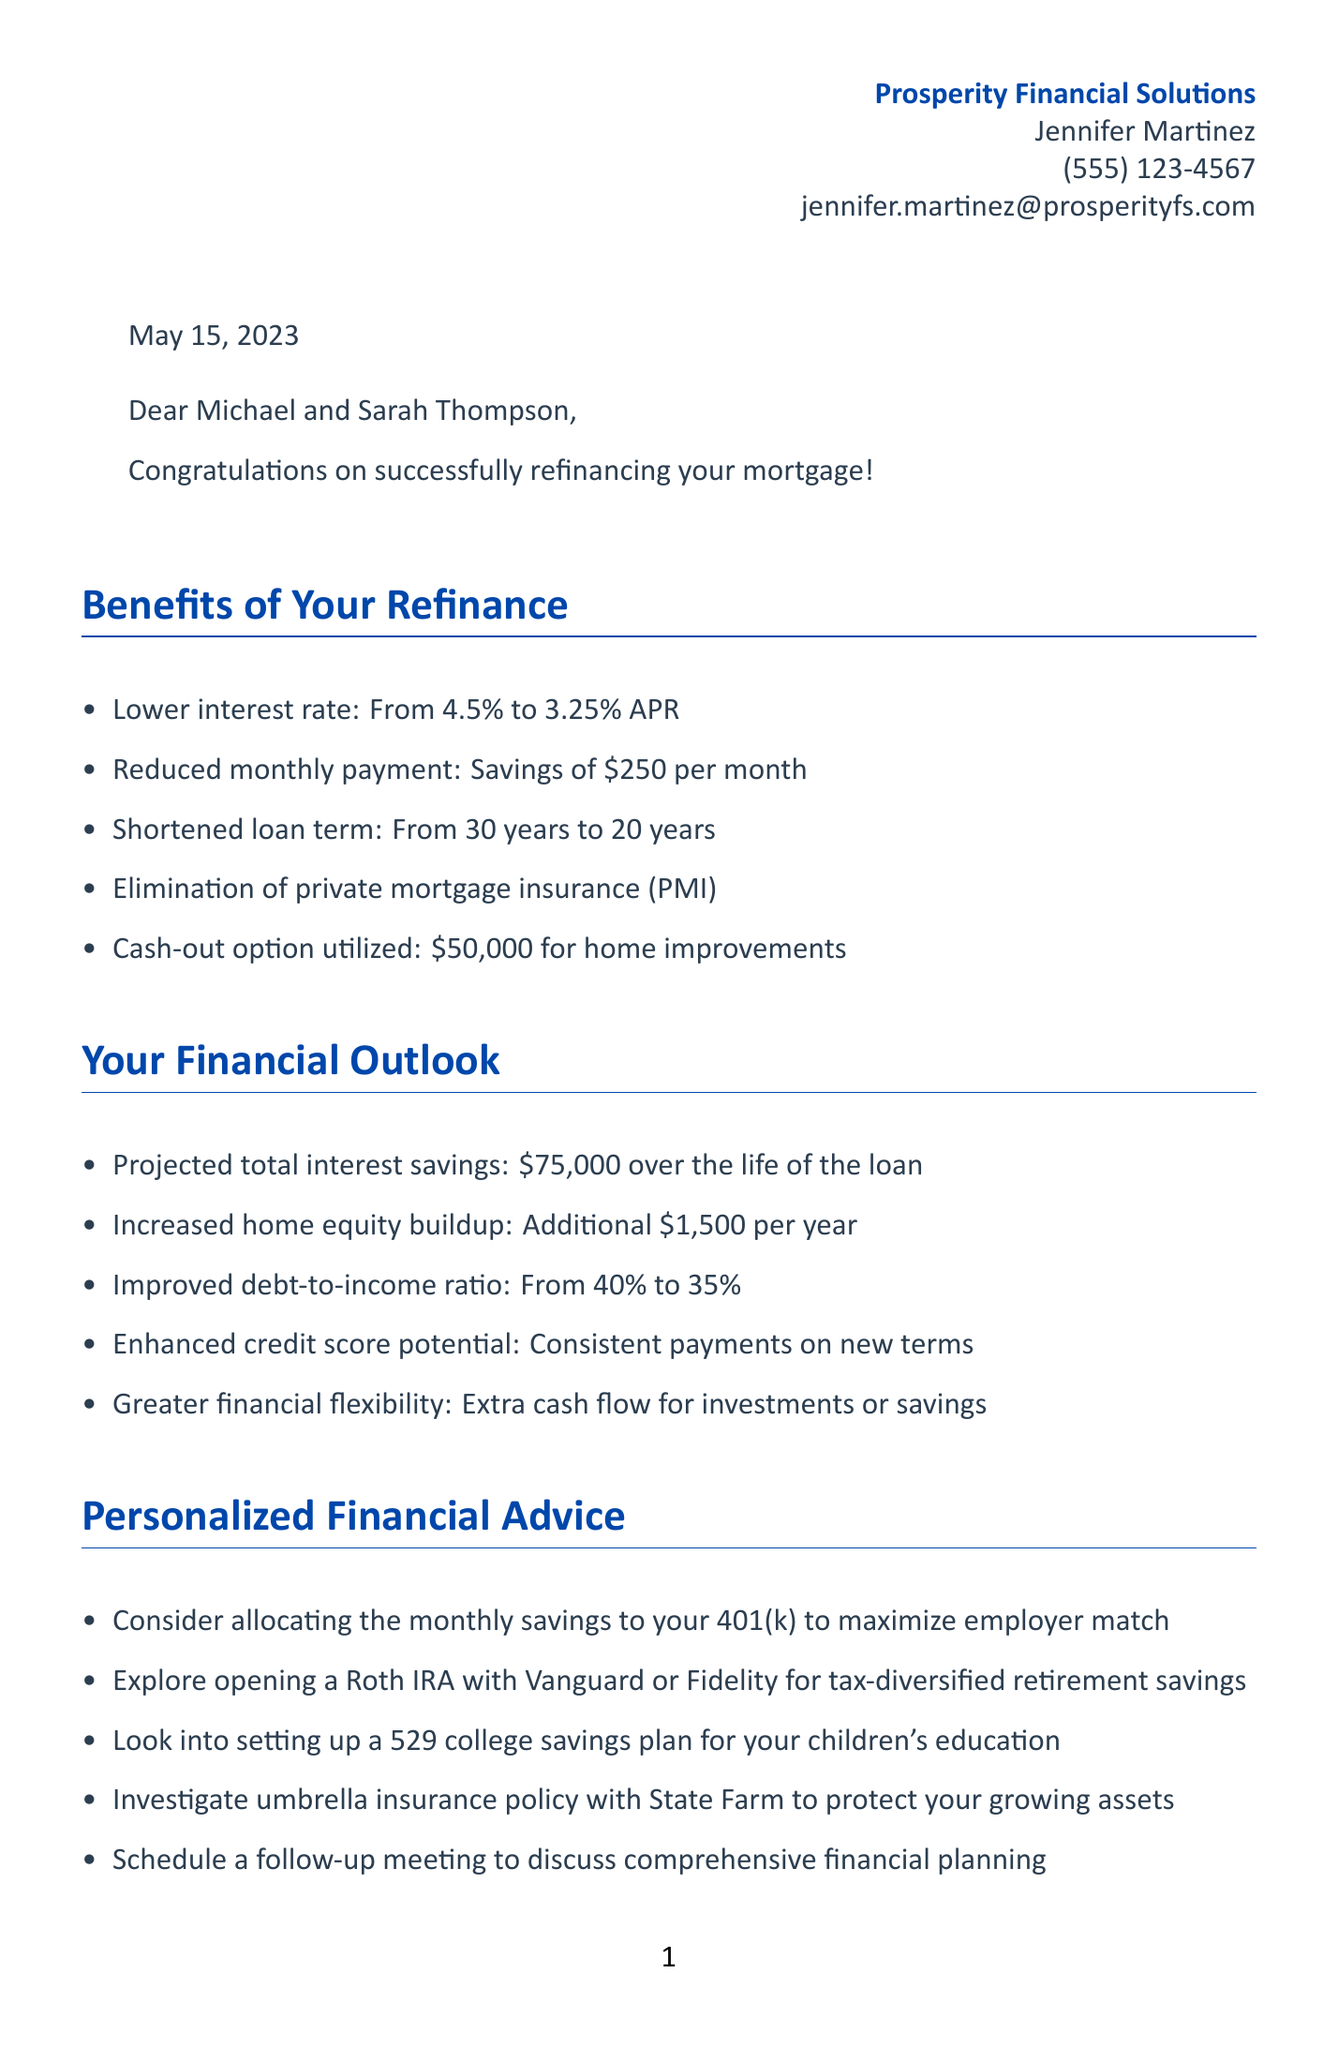What are the names of the clients? The document addresses Michael and Sarah Thompson, who are the clients.
Answer: Michael and Sarah Thompson What is the original lender's name? The document mentions that the clients' original lender was Bank of America.
Answer: Bank of America What is the new interest rate after refinancing? The document states that the interest rate was lowered to 3.25% APR after refinancing.
Answer: 3.25% APR What is the projected total interest savings? The total interest savings projected over the life of the loan is noted as $75,000.
Answer: $75,000 How much is the monthly savings? The clients are saving $250 per month on their mortgage payments as stated in the document.
Answer: $250 What should the clients do with their budget according to the next steps? The document advises the clients to update their budget to reflect the new monthly payment.
Answer: Update budget What financial planning topic is suggested for follow-up? The document suggests scheduling a follow-up meeting to discuss comprehensive financial planning.
Answer: Comprehensive financial planning What is an example of personalized financial advice given? The document suggests considering allocating the monthly savings to the clients' 401(k) to maximize employer match.
Answer: Allocate to 401(k) What is the date of the refinance? The refinance date mentioned in the document is May 15, 2023.
Answer: May 15, 2023 